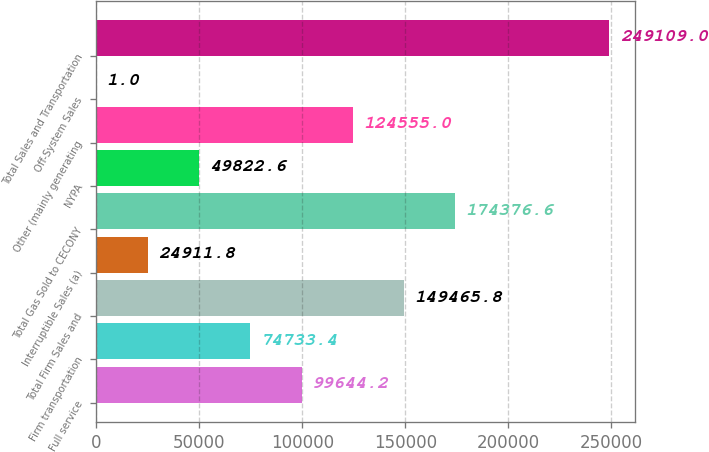<chart> <loc_0><loc_0><loc_500><loc_500><bar_chart><fcel>Full service<fcel>Firm transportation<fcel>Total Firm Sales and<fcel>Interruptible Sales (a)<fcel>Total Gas Sold to CECONY<fcel>NYPA<fcel>Other (mainly generating<fcel>Off-System Sales<fcel>Total Sales and Transportation<nl><fcel>99644.2<fcel>74733.4<fcel>149466<fcel>24911.8<fcel>174377<fcel>49822.6<fcel>124555<fcel>1<fcel>249109<nl></chart> 